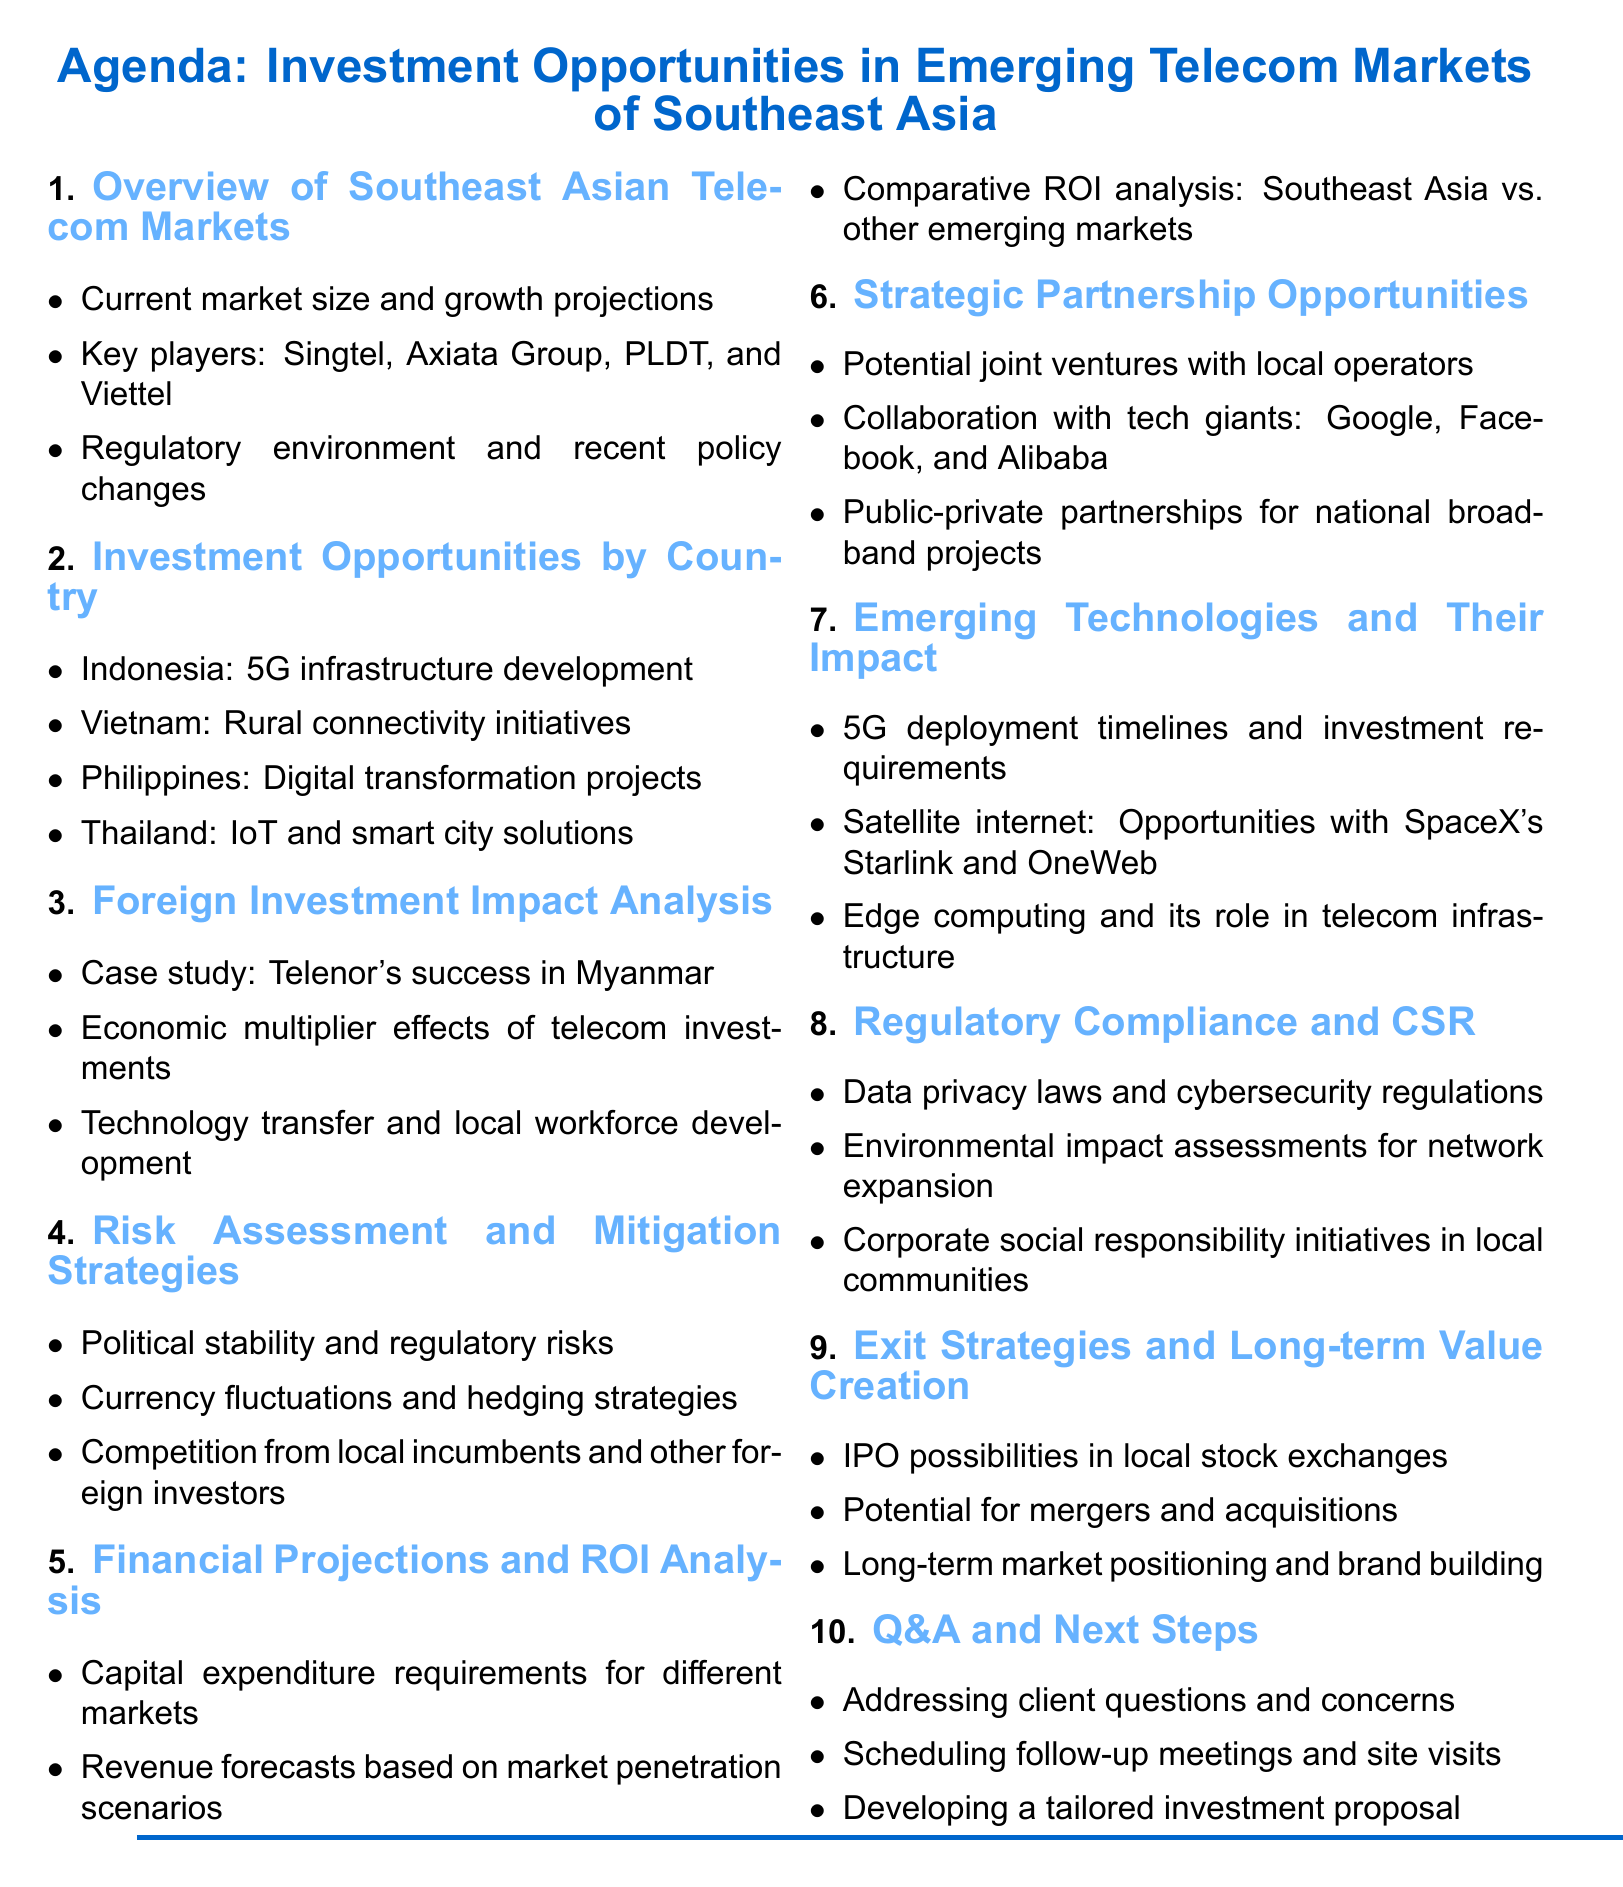What are the key players in the telecom market? The key players mentioned include Singtel, Axiata Group, PLDT, and Viettel.
Answer: Singtel, Axiata Group, PLDT, Viettel What investment opportunity is highlighted for Thailand? The agenda lists "IoT and smart city solutions" as an investment opportunity for Thailand.
Answer: IoT and smart city solutions Which country's telecom investment case study is highlighted? The document presents a case study on Telenor's success in Myanmar.
Answer: Myanmar What are the potential risks listed in the agenda? The risks include political stability, regulatory risks, currency fluctuations, and competition.
Answer: Political stability, regulatory risks, currency fluctuations, competition What do the financial projections include for different markets? The projections address capital expenditure requirements, revenue forecasts, and comparative ROI analysis.
Answer: Capital expenditure requirements, revenue forecasts, comparative ROI analysis What type of partnerships are recommended in the document? The agenda suggests exploring joint ventures, tech giant collaborations, and public-private partnerships.
Answer: Joint ventures, collaborations, public-private partnerships What is the focus of the section on emerging technologies? The focus includes 5G deployment, satellite internet opportunities, and edge computing's impact.
Answer: 5G deployment, satellite internet, edge computing What strategies are mentioned for mitigating risks? Strategies include managing currency fluctuations and assessing political stability and competition.
Answer: Currency fluctuations, political stability, competition 